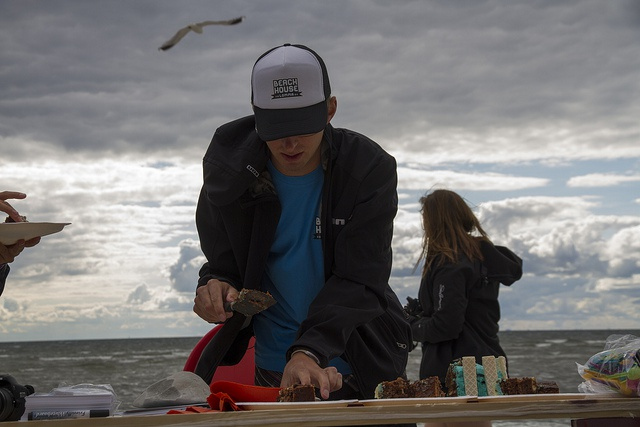Describe the objects in this image and their specific colors. I can see people in gray, black, navy, and maroon tones, dining table in gray, black, and maroon tones, people in gray, black, and darkgray tones, cake in gray, black, and teal tones, and book in gray tones in this image. 